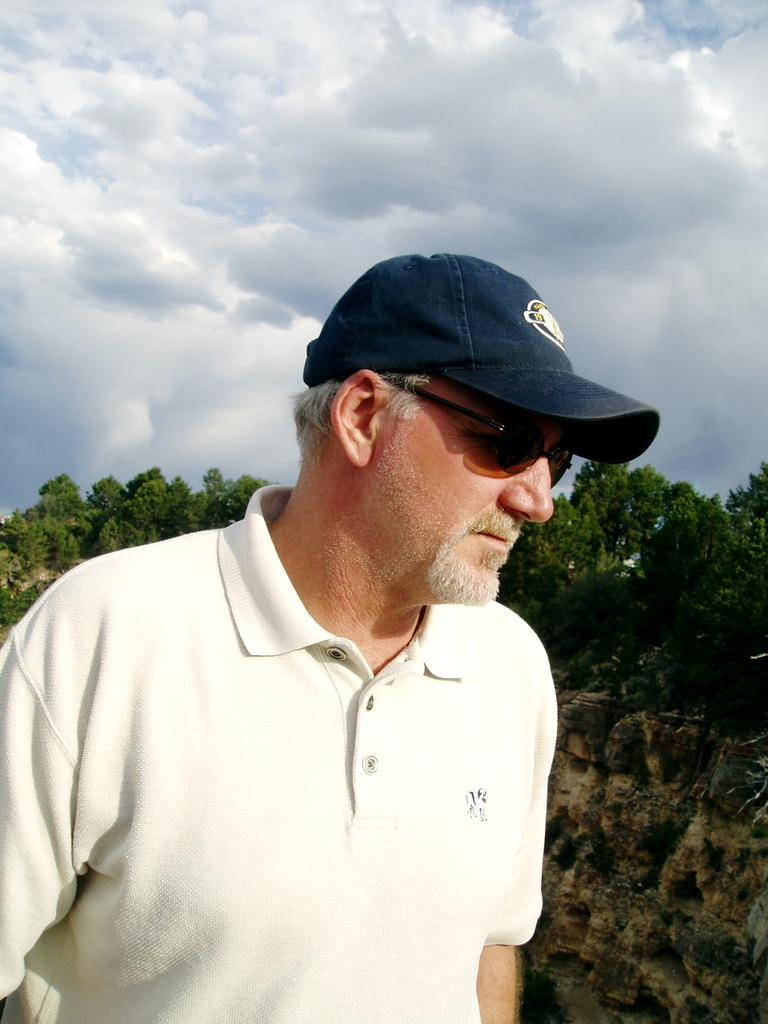Who or what is the main subject of the image? There is a person in the image. What is the person wearing on their head? The person is wearing a cap. What can be seen in the background of the image? There are trees and the sky visible in the background of the image. What type of jeans is the person wearing in the image? There is no information about the person's jeans in the image, so it cannot be determined. 